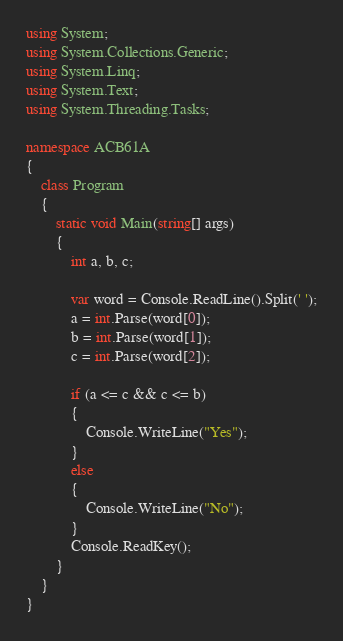Convert code to text. <code><loc_0><loc_0><loc_500><loc_500><_C#_>using System;
using System.Collections.Generic;
using System.Linq;
using System.Text;
using System.Threading.Tasks;

namespace ACB61A
{
    class Program
    {
        static void Main(string[] args)
        {
            int a, b, c;

            var word = Console.ReadLine().Split(' ');
            a = int.Parse(word[0]);
            b = int.Parse(word[1]);
            c = int.Parse(word[2]);

            if (a <= c && c <= b)
            {
                Console.WriteLine("Yes");
            }
            else
            {
                Console.WriteLine("No");
            }
            Console.ReadKey();
        }
    }
}
</code> 